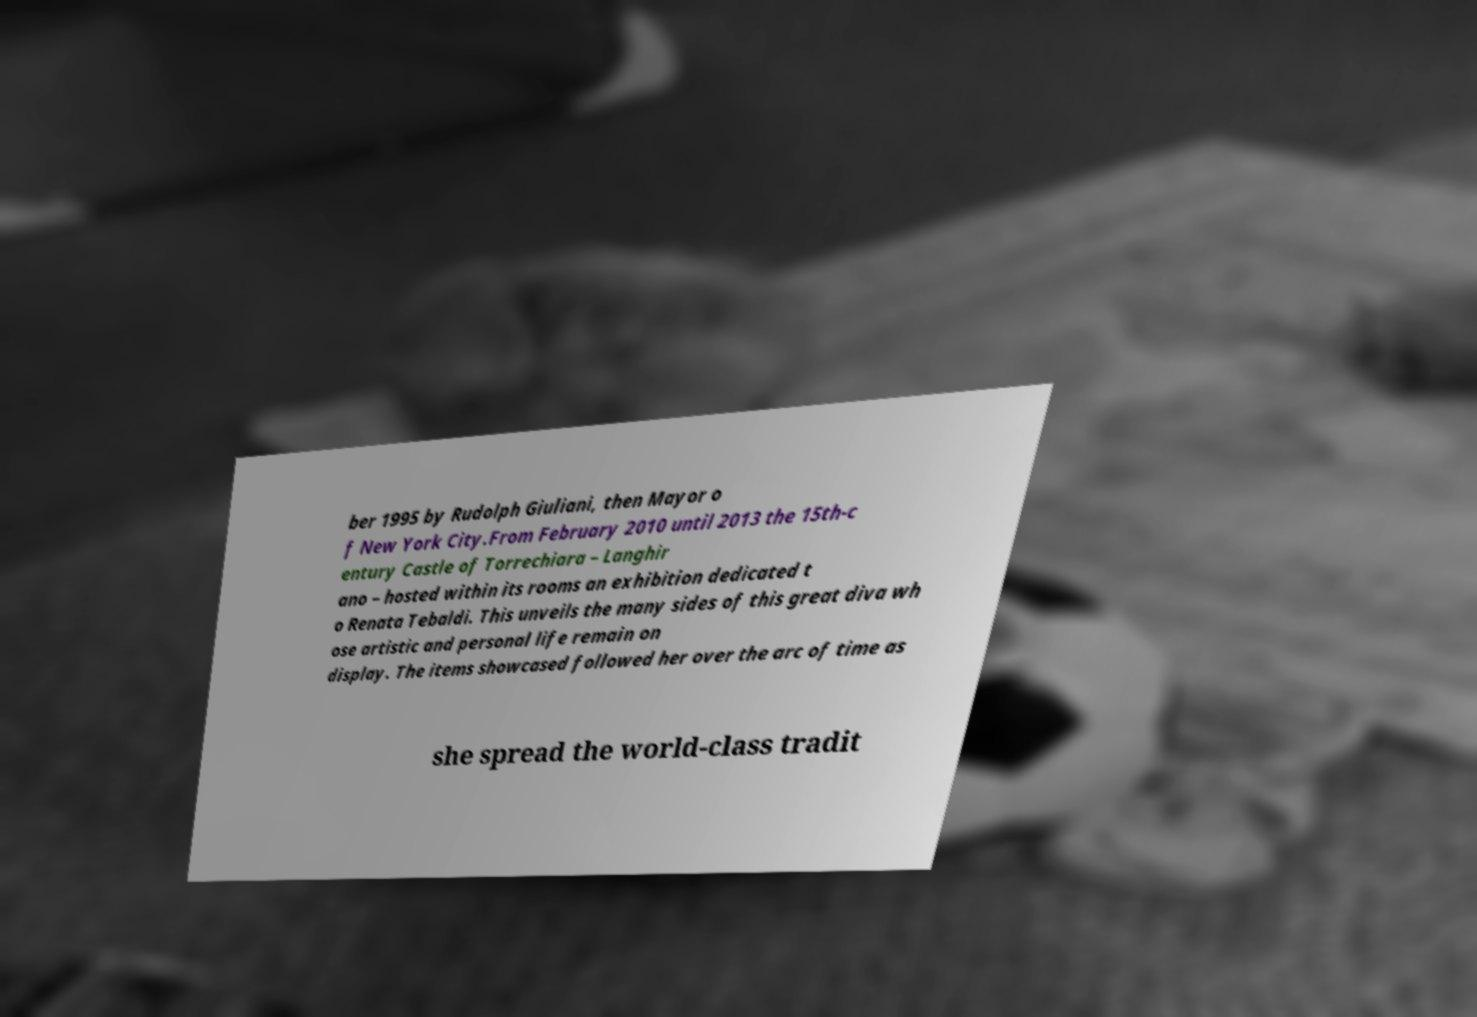Could you assist in decoding the text presented in this image and type it out clearly? ber 1995 by Rudolph Giuliani, then Mayor o f New York City.From February 2010 until 2013 the 15th-c entury Castle of Torrechiara – Langhir ano – hosted within its rooms an exhibition dedicated t o Renata Tebaldi. This unveils the many sides of this great diva wh ose artistic and personal life remain on display. The items showcased followed her over the arc of time as she spread the world-class tradit 